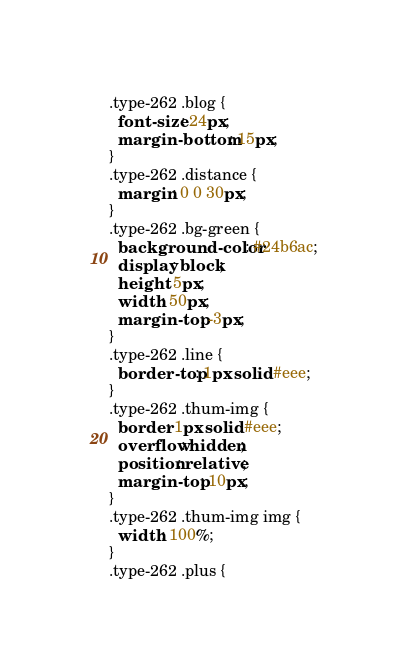<code> <loc_0><loc_0><loc_500><loc_500><_CSS_>.type-262 .blog {
  font-size: 24px;
  margin-bottom: 15px;
}
.type-262 .distance {
  margin: 0 0 30px;
}
.type-262 .bg-green {
  background-color: #24b6ac;
  display: block;
  height: 5px;
  width: 50px;
  margin-top: -3px;
}
.type-262 .line {
  border-top: 1px solid #eee;
}
.type-262 .thum-img {
  border: 1px solid #eee;
  overflow: hidden;
  position: relative;
  margin-top: 10px;
}
.type-262 .thum-img img {
  width: 100%;
}
.type-262 .plus {</code> 